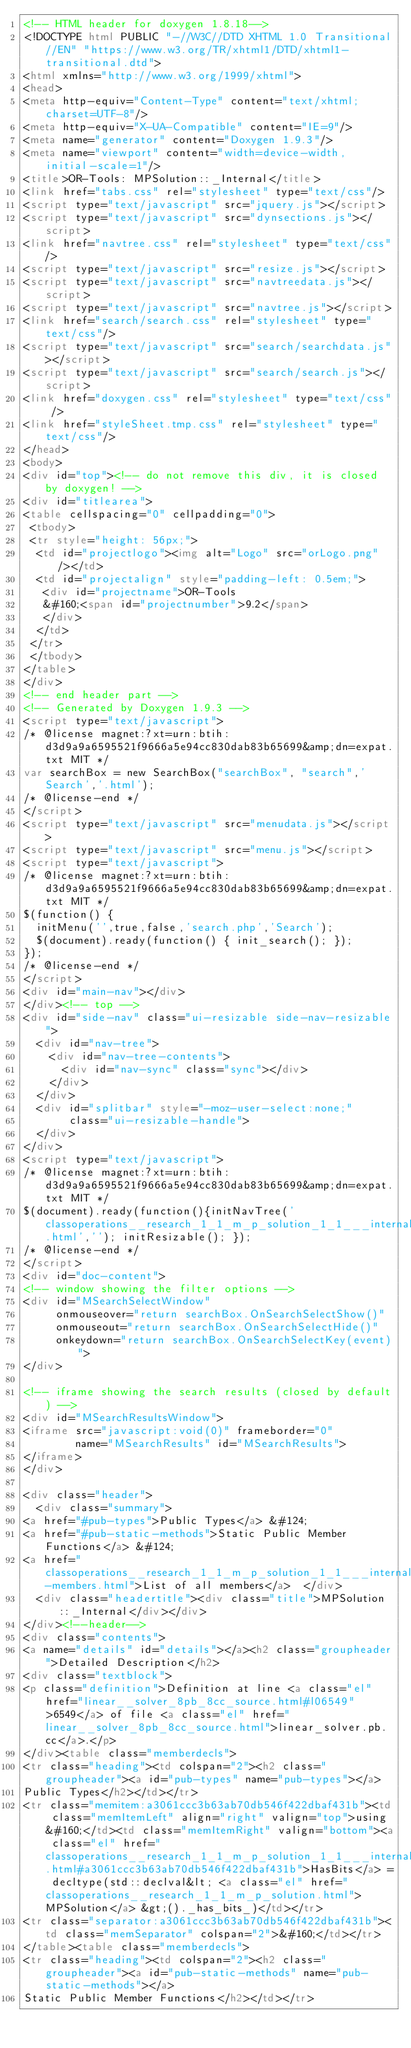<code> <loc_0><loc_0><loc_500><loc_500><_HTML_><!-- HTML header for doxygen 1.8.18-->
<!DOCTYPE html PUBLIC "-//W3C//DTD XHTML 1.0 Transitional//EN" "https://www.w3.org/TR/xhtml1/DTD/xhtml1-transitional.dtd">
<html xmlns="http://www.w3.org/1999/xhtml">
<head>
<meta http-equiv="Content-Type" content="text/xhtml;charset=UTF-8"/>
<meta http-equiv="X-UA-Compatible" content="IE=9"/>
<meta name="generator" content="Doxygen 1.9.3"/>
<meta name="viewport" content="width=device-width, initial-scale=1"/>
<title>OR-Tools: MPSolution::_Internal</title>
<link href="tabs.css" rel="stylesheet" type="text/css"/>
<script type="text/javascript" src="jquery.js"></script>
<script type="text/javascript" src="dynsections.js"></script>
<link href="navtree.css" rel="stylesheet" type="text/css"/>
<script type="text/javascript" src="resize.js"></script>
<script type="text/javascript" src="navtreedata.js"></script>
<script type="text/javascript" src="navtree.js"></script>
<link href="search/search.css" rel="stylesheet" type="text/css"/>
<script type="text/javascript" src="search/searchdata.js"></script>
<script type="text/javascript" src="search/search.js"></script>
<link href="doxygen.css" rel="stylesheet" type="text/css" />
<link href="styleSheet.tmp.css" rel="stylesheet" type="text/css"/>
</head>
<body>
<div id="top"><!-- do not remove this div, it is closed by doxygen! -->
<div id="titlearea">
<table cellspacing="0" cellpadding="0">
 <tbody>
 <tr style="height: 56px;">
  <td id="projectlogo"><img alt="Logo" src="orLogo.png"/></td>
  <td id="projectalign" style="padding-left: 0.5em;">
   <div id="projectname">OR-Tools
   &#160;<span id="projectnumber">9.2</span>
   </div>
  </td>
 </tr>
 </tbody>
</table>
</div>
<!-- end header part -->
<!-- Generated by Doxygen 1.9.3 -->
<script type="text/javascript">
/* @license magnet:?xt=urn:btih:d3d9a9a6595521f9666a5e94cc830dab83b65699&amp;dn=expat.txt MIT */
var searchBox = new SearchBox("searchBox", "search",'Search','.html');
/* @license-end */
</script>
<script type="text/javascript" src="menudata.js"></script>
<script type="text/javascript" src="menu.js"></script>
<script type="text/javascript">
/* @license magnet:?xt=urn:btih:d3d9a9a6595521f9666a5e94cc830dab83b65699&amp;dn=expat.txt MIT */
$(function() {
  initMenu('',true,false,'search.php','Search');
  $(document).ready(function() { init_search(); });
});
/* @license-end */
</script>
<div id="main-nav"></div>
</div><!-- top -->
<div id="side-nav" class="ui-resizable side-nav-resizable">
  <div id="nav-tree">
    <div id="nav-tree-contents">
      <div id="nav-sync" class="sync"></div>
    </div>
  </div>
  <div id="splitbar" style="-moz-user-select:none;" 
       class="ui-resizable-handle">
  </div>
</div>
<script type="text/javascript">
/* @license magnet:?xt=urn:btih:d3d9a9a6595521f9666a5e94cc830dab83b65699&amp;dn=expat.txt MIT */
$(document).ready(function(){initNavTree('classoperations__research_1_1_m_p_solution_1_1___internal.html',''); initResizable(); });
/* @license-end */
</script>
<div id="doc-content">
<!-- window showing the filter options -->
<div id="MSearchSelectWindow"
     onmouseover="return searchBox.OnSearchSelectShow()"
     onmouseout="return searchBox.OnSearchSelectHide()"
     onkeydown="return searchBox.OnSearchSelectKey(event)">
</div>

<!-- iframe showing the search results (closed by default) -->
<div id="MSearchResultsWindow">
<iframe src="javascript:void(0)" frameborder="0" 
        name="MSearchResults" id="MSearchResults">
</iframe>
</div>

<div class="header">
  <div class="summary">
<a href="#pub-types">Public Types</a> &#124;
<a href="#pub-static-methods">Static Public Member Functions</a> &#124;
<a href="classoperations__research_1_1_m_p_solution_1_1___internal-members.html">List of all members</a>  </div>
  <div class="headertitle"><div class="title">MPSolution::_Internal</div></div>
</div><!--header-->
<div class="contents">
<a name="details" id="details"></a><h2 class="groupheader">Detailed Description</h2>
<div class="textblock">
<p class="definition">Definition at line <a class="el" href="linear__solver_8pb_8cc_source.html#l06549">6549</a> of file <a class="el" href="linear__solver_8pb_8cc_source.html">linear_solver.pb.cc</a>.</p>
</div><table class="memberdecls">
<tr class="heading"><td colspan="2"><h2 class="groupheader"><a id="pub-types" name="pub-types"></a>
Public Types</h2></td></tr>
<tr class="memitem:a3061ccc3b63ab70db546f422dbaf431b"><td class="memItemLeft" align="right" valign="top">using&#160;</td><td class="memItemRight" valign="bottom"><a class="el" href="classoperations__research_1_1_m_p_solution_1_1___internal.html#a3061ccc3b63ab70db546f422dbaf431b">HasBits</a> = decltype(std::declval&lt; <a class="el" href="classoperations__research_1_1_m_p_solution.html">MPSolution</a> &gt;()._has_bits_)</td></tr>
<tr class="separator:a3061ccc3b63ab70db546f422dbaf431b"><td class="memSeparator" colspan="2">&#160;</td></tr>
</table><table class="memberdecls">
<tr class="heading"><td colspan="2"><h2 class="groupheader"><a id="pub-static-methods" name="pub-static-methods"></a>
Static Public Member Functions</h2></td></tr></code> 